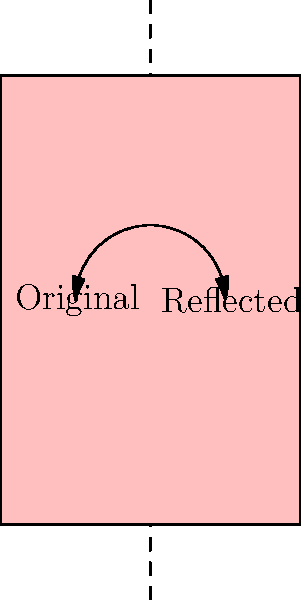In a virtual book application, a digital page-turning animation is reflected across a plane to create a mirrored effect. If the original animation moves the page from point $A(0,0)$ to point $B(2,3)$, and the plane of reflection is described by the equation $x=1$, what are the coordinates of point $B'$, the reflection of point $B$? To find the coordinates of the reflected point $B'$, we need to follow these steps:

1) The plane of reflection is given by $x=1$. This means it's a vertical line that passes through $x=1$.

2) The original point $B$ has coordinates $(2,3)$.

3) To reflect a point across the line $x=1$, we need to:
   a) Calculate the distance of the point from the line of reflection.
   b) Double this distance and subtract it from the x-coordinate of the original point.

4) The distance of point $B$ from the line $x=1$ is:
   $2 - 1 = 1$

5) Doubling this distance: $1 * 2 = 2$

6) Subtracting from the original x-coordinate:
   $2 - 2 = 0$

7) The y-coordinate remains unchanged in a reflection across a vertical line.

Therefore, the coordinates of $B'$ are $(0,3)$.
Answer: $(0,3)$ 